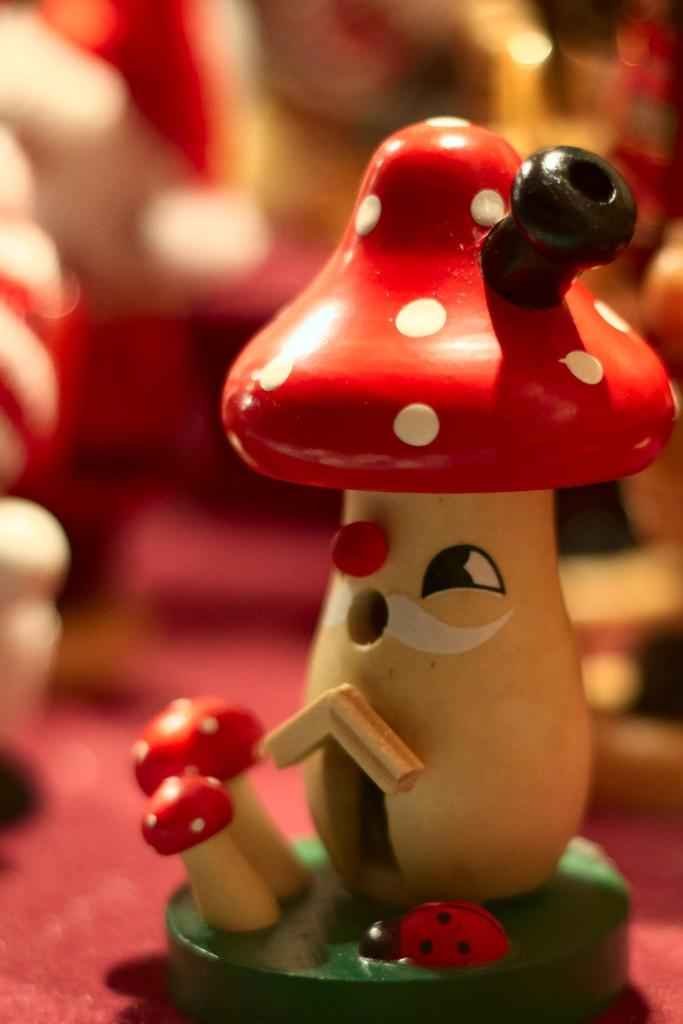What type of organisms can be seen in the image? There are mushrooms and an insect depicted in the image. Can you describe the background of the image? The background of the image appears blurred. What type of baseball activity is taking place in the image? There is no baseball activity present in the image; it features mushrooms and an insect. What type of kick is being performed by the mushroom in the image? There is no kick being performed by the mushroom in the image, as mushrooms do not have the ability to kick. 